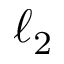Convert formula to latex. <formula><loc_0><loc_0><loc_500><loc_500>\ell _ { 2 }</formula> 